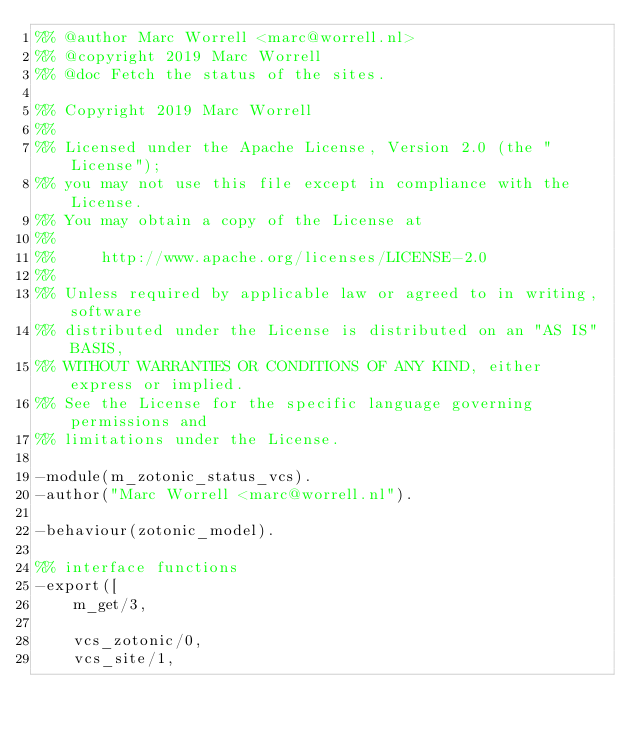<code> <loc_0><loc_0><loc_500><loc_500><_Erlang_>%% @author Marc Worrell <marc@worrell.nl>
%% @copyright 2019 Marc Worrell
%% @doc Fetch the status of the sites.

%% Copyright 2019 Marc Worrell
%%
%% Licensed under the Apache License, Version 2.0 (the "License");
%% you may not use this file except in compliance with the License.
%% You may obtain a copy of the License at
%%
%%     http://www.apache.org/licenses/LICENSE-2.0
%%
%% Unless required by applicable law or agreed to in writing, software
%% distributed under the License is distributed on an "AS IS" BASIS,
%% WITHOUT WARRANTIES OR CONDITIONS OF ANY KIND, either express or implied.
%% See the License for the specific language governing permissions and
%% limitations under the License.

-module(m_zotonic_status_vcs).
-author("Marc Worrell <marc@worrell.nl").

-behaviour(zotonic_model).

%% interface functions
-export([
    m_get/3,

    vcs_zotonic/0,
    vcs_site/1,</code> 